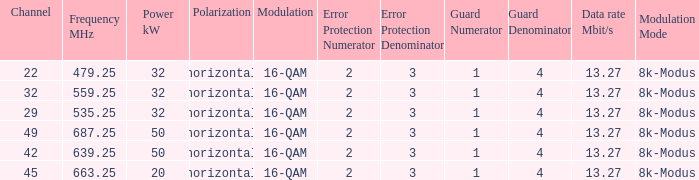On channel 32, when the power is 32 kW horizontal, what is the modulation? 16-QAM. 